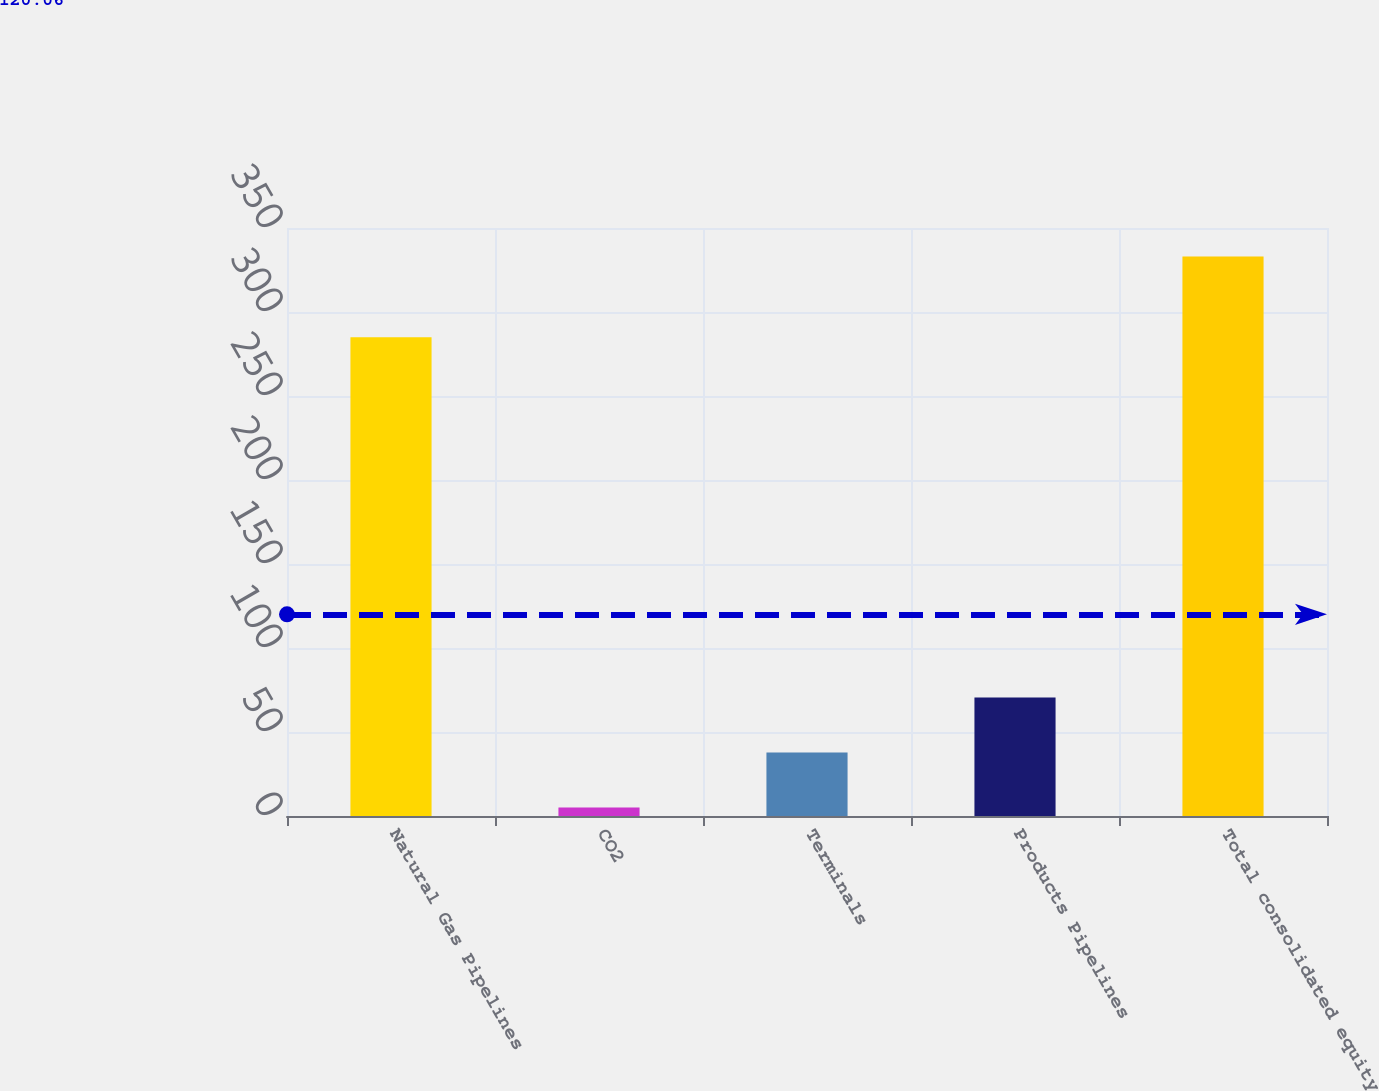Convert chart. <chart><loc_0><loc_0><loc_500><loc_500><bar_chart><fcel>Natural Gas Pipelines<fcel>CO2<fcel>Terminals<fcel>Products Pipelines<fcel>Total consolidated equity<nl><fcel>285<fcel>5<fcel>37.8<fcel>70.6<fcel>333<nl></chart> 